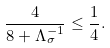Convert formula to latex. <formula><loc_0><loc_0><loc_500><loc_500>\frac { 4 } { 8 + \Lambda _ { \sigma } ^ { - 1 } } \leq \frac { 1 } { 4 } .</formula> 